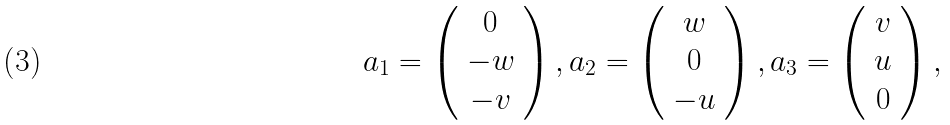Convert formula to latex. <formula><loc_0><loc_0><loc_500><loc_500>a _ { 1 } = \left ( \begin{array} { c } 0 \\ - w \\ - v \\ \end{array} \right ) , a _ { 2 } = \left ( \begin{array} { c } w \\ 0 \\ - u \\ \end{array} \right ) , a _ { 3 } = \left ( \begin{array} { c } v \\ u \\ 0 \\ \end{array} \right ) ,</formula> 